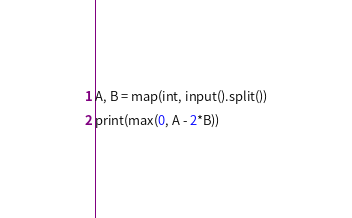<code> <loc_0><loc_0><loc_500><loc_500><_Python_>A, B = map(int, input().split())
print(max(0, A - 2*B))</code> 